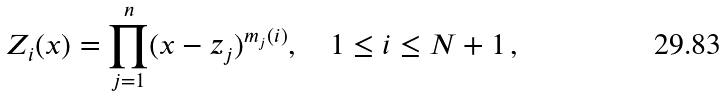Convert formula to latex. <formula><loc_0><loc_0><loc_500><loc_500>Z _ { i } ( x ) = \prod _ { j = 1 } ^ { n } ( x - z _ { j } ) ^ { m _ { j } ( i ) } , \quad 1 \leq i \leq N + 1 \, ,</formula> 